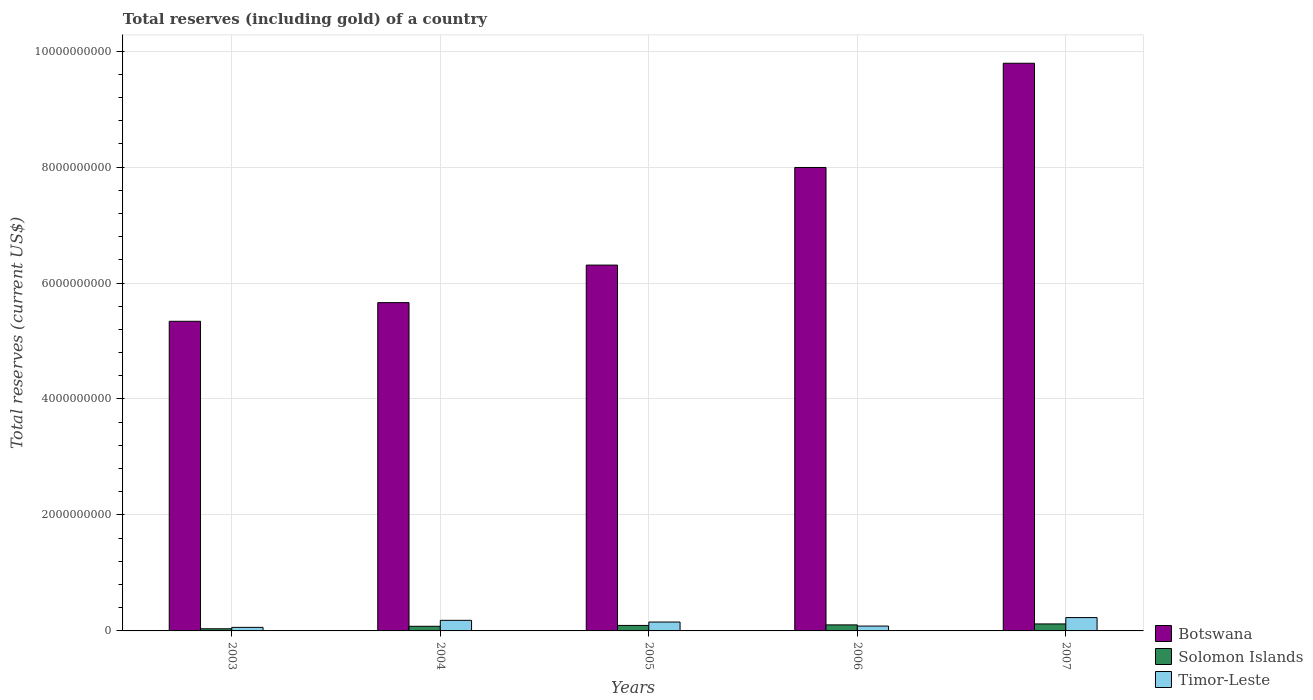How many different coloured bars are there?
Keep it short and to the point. 3. How many groups of bars are there?
Offer a very short reply. 5. Are the number of bars per tick equal to the number of legend labels?
Your answer should be very brief. Yes. Are the number of bars on each tick of the X-axis equal?
Your answer should be very brief. Yes. What is the label of the 3rd group of bars from the left?
Give a very brief answer. 2005. What is the total reserves (including gold) in Solomon Islands in 2006?
Keep it short and to the point. 1.04e+08. Across all years, what is the maximum total reserves (including gold) in Timor-Leste?
Offer a terse response. 2.30e+08. Across all years, what is the minimum total reserves (including gold) in Botswana?
Provide a short and direct response. 5.34e+09. In which year was the total reserves (including gold) in Timor-Leste maximum?
Provide a short and direct response. 2007. What is the total total reserves (including gold) in Botswana in the graph?
Your response must be concise. 3.51e+1. What is the difference between the total reserves (including gold) in Timor-Leste in 2003 and that in 2006?
Give a very brief answer. -2.25e+07. What is the difference between the total reserves (including gold) in Timor-Leste in 2003 and the total reserves (including gold) in Solomon Islands in 2006?
Give a very brief answer. -4.28e+07. What is the average total reserves (including gold) in Solomon Islands per year?
Offer a very short reply. 8.72e+07. In the year 2007, what is the difference between the total reserves (including gold) in Timor-Leste and total reserves (including gold) in Botswana?
Offer a terse response. -9.56e+09. In how many years, is the total reserves (including gold) in Timor-Leste greater than 4000000000 US$?
Provide a short and direct response. 0. What is the ratio of the total reserves (including gold) in Timor-Leste in 2003 to that in 2004?
Give a very brief answer. 0.34. Is the difference between the total reserves (including gold) in Timor-Leste in 2003 and 2006 greater than the difference between the total reserves (including gold) in Botswana in 2003 and 2006?
Your response must be concise. Yes. What is the difference between the highest and the second highest total reserves (including gold) in Solomon Islands?
Offer a very short reply. 1.65e+07. What is the difference between the highest and the lowest total reserves (including gold) in Timor-Leste?
Give a very brief answer. 1.69e+08. In how many years, is the total reserves (including gold) in Solomon Islands greater than the average total reserves (including gold) in Solomon Islands taken over all years?
Offer a very short reply. 3. Is the sum of the total reserves (including gold) in Solomon Islands in 2004 and 2005 greater than the maximum total reserves (including gold) in Timor-Leste across all years?
Your answer should be very brief. No. What does the 1st bar from the left in 2007 represents?
Make the answer very short. Botswana. What does the 2nd bar from the right in 2007 represents?
Your response must be concise. Solomon Islands. How many bars are there?
Ensure brevity in your answer.  15. Are the values on the major ticks of Y-axis written in scientific E-notation?
Keep it short and to the point. No. Does the graph contain any zero values?
Provide a succinct answer. No. Does the graph contain grids?
Make the answer very short. Yes. How are the legend labels stacked?
Your answer should be compact. Vertical. What is the title of the graph?
Offer a very short reply. Total reserves (including gold) of a country. What is the label or title of the Y-axis?
Your answer should be compact. Total reserves (current US$). What is the Total reserves (current US$) of Botswana in 2003?
Provide a short and direct response. 5.34e+09. What is the Total reserves (current US$) of Solomon Islands in 2003?
Provide a succinct answer. 3.70e+07. What is the Total reserves (current US$) of Timor-Leste in 2003?
Offer a terse response. 6.13e+07. What is the Total reserves (current US$) in Botswana in 2004?
Your response must be concise. 5.66e+09. What is the Total reserves (current US$) of Solomon Islands in 2004?
Your response must be concise. 7.98e+07. What is the Total reserves (current US$) in Timor-Leste in 2004?
Offer a very short reply. 1.82e+08. What is the Total reserves (current US$) in Botswana in 2005?
Provide a succinct answer. 6.31e+09. What is the Total reserves (current US$) of Solomon Islands in 2005?
Your answer should be very brief. 9.48e+07. What is the Total reserves (current US$) of Timor-Leste in 2005?
Your answer should be compact. 1.53e+08. What is the Total reserves (current US$) in Botswana in 2006?
Keep it short and to the point. 7.99e+09. What is the Total reserves (current US$) of Solomon Islands in 2006?
Offer a very short reply. 1.04e+08. What is the Total reserves (current US$) of Timor-Leste in 2006?
Give a very brief answer. 8.38e+07. What is the Total reserves (current US$) of Botswana in 2007?
Provide a short and direct response. 9.79e+09. What is the Total reserves (current US$) in Solomon Islands in 2007?
Give a very brief answer. 1.21e+08. What is the Total reserves (current US$) of Timor-Leste in 2007?
Keep it short and to the point. 2.30e+08. Across all years, what is the maximum Total reserves (current US$) in Botswana?
Ensure brevity in your answer.  9.79e+09. Across all years, what is the maximum Total reserves (current US$) of Solomon Islands?
Make the answer very short. 1.21e+08. Across all years, what is the maximum Total reserves (current US$) of Timor-Leste?
Provide a succinct answer. 2.30e+08. Across all years, what is the minimum Total reserves (current US$) of Botswana?
Ensure brevity in your answer.  5.34e+09. Across all years, what is the minimum Total reserves (current US$) in Solomon Islands?
Provide a succinct answer. 3.70e+07. Across all years, what is the minimum Total reserves (current US$) in Timor-Leste?
Provide a succinct answer. 6.13e+07. What is the total Total reserves (current US$) of Botswana in the graph?
Ensure brevity in your answer.  3.51e+1. What is the total Total reserves (current US$) of Solomon Islands in the graph?
Give a very brief answer. 4.36e+08. What is the total Total reserves (current US$) of Timor-Leste in the graph?
Give a very brief answer. 7.11e+08. What is the difference between the Total reserves (current US$) of Botswana in 2003 and that in 2004?
Offer a very short reply. -3.22e+08. What is the difference between the Total reserves (current US$) of Solomon Islands in 2003 and that in 2004?
Offer a very short reply. -4.28e+07. What is the difference between the Total reserves (current US$) in Timor-Leste in 2003 and that in 2004?
Give a very brief answer. -1.21e+08. What is the difference between the Total reserves (current US$) in Botswana in 2003 and that in 2005?
Give a very brief answer. -9.69e+08. What is the difference between the Total reserves (current US$) of Solomon Islands in 2003 and that in 2005?
Offer a very short reply. -5.78e+07. What is the difference between the Total reserves (current US$) of Timor-Leste in 2003 and that in 2005?
Your response must be concise. -9.20e+07. What is the difference between the Total reserves (current US$) in Botswana in 2003 and that in 2006?
Your answer should be compact. -2.65e+09. What is the difference between the Total reserves (current US$) in Solomon Islands in 2003 and that in 2006?
Provide a succinct answer. -6.71e+07. What is the difference between the Total reserves (current US$) of Timor-Leste in 2003 and that in 2006?
Your answer should be compact. -2.25e+07. What is the difference between the Total reserves (current US$) of Botswana in 2003 and that in 2007?
Your answer should be compact. -4.45e+09. What is the difference between the Total reserves (current US$) in Solomon Islands in 2003 and that in 2007?
Offer a terse response. -8.35e+07. What is the difference between the Total reserves (current US$) in Timor-Leste in 2003 and that in 2007?
Provide a succinct answer. -1.69e+08. What is the difference between the Total reserves (current US$) in Botswana in 2004 and that in 2005?
Your answer should be compact. -6.48e+08. What is the difference between the Total reserves (current US$) of Solomon Islands in 2004 and that in 2005?
Ensure brevity in your answer.  -1.50e+07. What is the difference between the Total reserves (current US$) of Timor-Leste in 2004 and that in 2005?
Provide a short and direct response. 2.91e+07. What is the difference between the Total reserves (current US$) in Botswana in 2004 and that in 2006?
Offer a terse response. -2.33e+09. What is the difference between the Total reserves (current US$) of Solomon Islands in 2004 and that in 2006?
Your response must be concise. -2.43e+07. What is the difference between the Total reserves (current US$) of Timor-Leste in 2004 and that in 2006?
Give a very brief answer. 9.87e+07. What is the difference between the Total reserves (current US$) of Botswana in 2004 and that in 2007?
Keep it short and to the point. -4.13e+09. What is the difference between the Total reserves (current US$) in Solomon Islands in 2004 and that in 2007?
Ensure brevity in your answer.  -4.07e+07. What is the difference between the Total reserves (current US$) of Timor-Leste in 2004 and that in 2007?
Make the answer very short. -4.78e+07. What is the difference between the Total reserves (current US$) in Botswana in 2005 and that in 2006?
Your answer should be very brief. -1.68e+09. What is the difference between the Total reserves (current US$) in Solomon Islands in 2005 and that in 2006?
Your response must be concise. -9.25e+06. What is the difference between the Total reserves (current US$) of Timor-Leste in 2005 and that in 2006?
Your answer should be very brief. 6.95e+07. What is the difference between the Total reserves (current US$) of Botswana in 2005 and that in 2007?
Offer a terse response. -3.48e+09. What is the difference between the Total reserves (current US$) in Solomon Islands in 2005 and that in 2007?
Provide a short and direct response. -2.57e+07. What is the difference between the Total reserves (current US$) of Timor-Leste in 2005 and that in 2007?
Your response must be concise. -7.70e+07. What is the difference between the Total reserves (current US$) of Botswana in 2006 and that in 2007?
Provide a short and direct response. -1.80e+09. What is the difference between the Total reserves (current US$) of Solomon Islands in 2006 and that in 2007?
Give a very brief answer. -1.65e+07. What is the difference between the Total reserves (current US$) in Timor-Leste in 2006 and that in 2007?
Provide a short and direct response. -1.47e+08. What is the difference between the Total reserves (current US$) of Botswana in 2003 and the Total reserves (current US$) of Solomon Islands in 2004?
Give a very brief answer. 5.26e+09. What is the difference between the Total reserves (current US$) in Botswana in 2003 and the Total reserves (current US$) in Timor-Leste in 2004?
Offer a terse response. 5.16e+09. What is the difference between the Total reserves (current US$) of Solomon Islands in 2003 and the Total reserves (current US$) of Timor-Leste in 2004?
Your answer should be compact. -1.45e+08. What is the difference between the Total reserves (current US$) in Botswana in 2003 and the Total reserves (current US$) in Solomon Islands in 2005?
Keep it short and to the point. 5.24e+09. What is the difference between the Total reserves (current US$) in Botswana in 2003 and the Total reserves (current US$) in Timor-Leste in 2005?
Your response must be concise. 5.19e+09. What is the difference between the Total reserves (current US$) of Solomon Islands in 2003 and the Total reserves (current US$) of Timor-Leste in 2005?
Your response must be concise. -1.16e+08. What is the difference between the Total reserves (current US$) in Botswana in 2003 and the Total reserves (current US$) in Solomon Islands in 2006?
Give a very brief answer. 5.24e+09. What is the difference between the Total reserves (current US$) in Botswana in 2003 and the Total reserves (current US$) in Timor-Leste in 2006?
Ensure brevity in your answer.  5.26e+09. What is the difference between the Total reserves (current US$) of Solomon Islands in 2003 and the Total reserves (current US$) of Timor-Leste in 2006?
Keep it short and to the point. -4.67e+07. What is the difference between the Total reserves (current US$) in Botswana in 2003 and the Total reserves (current US$) in Solomon Islands in 2007?
Keep it short and to the point. 5.22e+09. What is the difference between the Total reserves (current US$) in Botswana in 2003 and the Total reserves (current US$) in Timor-Leste in 2007?
Keep it short and to the point. 5.11e+09. What is the difference between the Total reserves (current US$) in Solomon Islands in 2003 and the Total reserves (current US$) in Timor-Leste in 2007?
Ensure brevity in your answer.  -1.93e+08. What is the difference between the Total reserves (current US$) in Botswana in 2004 and the Total reserves (current US$) in Solomon Islands in 2005?
Offer a very short reply. 5.57e+09. What is the difference between the Total reserves (current US$) in Botswana in 2004 and the Total reserves (current US$) in Timor-Leste in 2005?
Your response must be concise. 5.51e+09. What is the difference between the Total reserves (current US$) in Solomon Islands in 2004 and the Total reserves (current US$) in Timor-Leste in 2005?
Provide a short and direct response. -7.35e+07. What is the difference between the Total reserves (current US$) of Botswana in 2004 and the Total reserves (current US$) of Solomon Islands in 2006?
Keep it short and to the point. 5.56e+09. What is the difference between the Total reserves (current US$) of Botswana in 2004 and the Total reserves (current US$) of Timor-Leste in 2006?
Offer a terse response. 5.58e+09. What is the difference between the Total reserves (current US$) of Solomon Islands in 2004 and the Total reserves (current US$) of Timor-Leste in 2006?
Offer a very short reply. -3.94e+06. What is the difference between the Total reserves (current US$) in Botswana in 2004 and the Total reserves (current US$) in Solomon Islands in 2007?
Provide a succinct answer. 5.54e+09. What is the difference between the Total reserves (current US$) in Botswana in 2004 and the Total reserves (current US$) in Timor-Leste in 2007?
Give a very brief answer. 5.43e+09. What is the difference between the Total reserves (current US$) in Solomon Islands in 2004 and the Total reserves (current US$) in Timor-Leste in 2007?
Provide a short and direct response. -1.50e+08. What is the difference between the Total reserves (current US$) in Botswana in 2005 and the Total reserves (current US$) in Solomon Islands in 2006?
Your answer should be very brief. 6.20e+09. What is the difference between the Total reserves (current US$) in Botswana in 2005 and the Total reserves (current US$) in Timor-Leste in 2006?
Provide a succinct answer. 6.23e+09. What is the difference between the Total reserves (current US$) in Solomon Islands in 2005 and the Total reserves (current US$) in Timor-Leste in 2006?
Offer a very short reply. 1.11e+07. What is the difference between the Total reserves (current US$) in Botswana in 2005 and the Total reserves (current US$) in Solomon Islands in 2007?
Provide a short and direct response. 6.19e+09. What is the difference between the Total reserves (current US$) in Botswana in 2005 and the Total reserves (current US$) in Timor-Leste in 2007?
Give a very brief answer. 6.08e+09. What is the difference between the Total reserves (current US$) of Solomon Islands in 2005 and the Total reserves (current US$) of Timor-Leste in 2007?
Your response must be concise. -1.35e+08. What is the difference between the Total reserves (current US$) of Botswana in 2006 and the Total reserves (current US$) of Solomon Islands in 2007?
Keep it short and to the point. 7.87e+09. What is the difference between the Total reserves (current US$) of Botswana in 2006 and the Total reserves (current US$) of Timor-Leste in 2007?
Your response must be concise. 7.76e+09. What is the difference between the Total reserves (current US$) in Solomon Islands in 2006 and the Total reserves (current US$) in Timor-Leste in 2007?
Offer a terse response. -1.26e+08. What is the average Total reserves (current US$) of Botswana per year?
Keep it short and to the point. 7.02e+09. What is the average Total reserves (current US$) of Solomon Islands per year?
Provide a succinct answer. 8.72e+07. What is the average Total reserves (current US$) of Timor-Leste per year?
Keep it short and to the point. 1.42e+08. In the year 2003, what is the difference between the Total reserves (current US$) in Botswana and Total reserves (current US$) in Solomon Islands?
Provide a succinct answer. 5.30e+09. In the year 2003, what is the difference between the Total reserves (current US$) in Botswana and Total reserves (current US$) in Timor-Leste?
Offer a very short reply. 5.28e+09. In the year 2003, what is the difference between the Total reserves (current US$) of Solomon Islands and Total reserves (current US$) of Timor-Leste?
Give a very brief answer. -2.43e+07. In the year 2004, what is the difference between the Total reserves (current US$) in Botswana and Total reserves (current US$) in Solomon Islands?
Provide a succinct answer. 5.58e+09. In the year 2004, what is the difference between the Total reserves (current US$) in Botswana and Total reserves (current US$) in Timor-Leste?
Make the answer very short. 5.48e+09. In the year 2004, what is the difference between the Total reserves (current US$) in Solomon Islands and Total reserves (current US$) in Timor-Leste?
Offer a very short reply. -1.03e+08. In the year 2005, what is the difference between the Total reserves (current US$) of Botswana and Total reserves (current US$) of Solomon Islands?
Your response must be concise. 6.21e+09. In the year 2005, what is the difference between the Total reserves (current US$) of Botswana and Total reserves (current US$) of Timor-Leste?
Your answer should be very brief. 6.16e+09. In the year 2005, what is the difference between the Total reserves (current US$) in Solomon Islands and Total reserves (current US$) in Timor-Leste?
Your response must be concise. -5.85e+07. In the year 2006, what is the difference between the Total reserves (current US$) of Botswana and Total reserves (current US$) of Solomon Islands?
Ensure brevity in your answer.  7.89e+09. In the year 2006, what is the difference between the Total reserves (current US$) of Botswana and Total reserves (current US$) of Timor-Leste?
Provide a succinct answer. 7.91e+09. In the year 2006, what is the difference between the Total reserves (current US$) in Solomon Islands and Total reserves (current US$) in Timor-Leste?
Give a very brief answer. 2.03e+07. In the year 2007, what is the difference between the Total reserves (current US$) in Botswana and Total reserves (current US$) in Solomon Islands?
Provide a short and direct response. 9.67e+09. In the year 2007, what is the difference between the Total reserves (current US$) in Botswana and Total reserves (current US$) in Timor-Leste?
Give a very brief answer. 9.56e+09. In the year 2007, what is the difference between the Total reserves (current US$) of Solomon Islands and Total reserves (current US$) of Timor-Leste?
Keep it short and to the point. -1.10e+08. What is the ratio of the Total reserves (current US$) of Botswana in 2003 to that in 2004?
Give a very brief answer. 0.94. What is the ratio of the Total reserves (current US$) of Solomon Islands in 2003 to that in 2004?
Keep it short and to the point. 0.46. What is the ratio of the Total reserves (current US$) in Timor-Leste in 2003 to that in 2004?
Provide a short and direct response. 0.34. What is the ratio of the Total reserves (current US$) in Botswana in 2003 to that in 2005?
Your answer should be compact. 0.85. What is the ratio of the Total reserves (current US$) of Solomon Islands in 2003 to that in 2005?
Your answer should be very brief. 0.39. What is the ratio of the Total reserves (current US$) in Timor-Leste in 2003 to that in 2005?
Ensure brevity in your answer.  0.4. What is the ratio of the Total reserves (current US$) of Botswana in 2003 to that in 2006?
Make the answer very short. 0.67. What is the ratio of the Total reserves (current US$) in Solomon Islands in 2003 to that in 2006?
Give a very brief answer. 0.36. What is the ratio of the Total reserves (current US$) of Timor-Leste in 2003 to that in 2006?
Your answer should be compact. 0.73. What is the ratio of the Total reserves (current US$) of Botswana in 2003 to that in 2007?
Offer a very short reply. 0.55. What is the ratio of the Total reserves (current US$) of Solomon Islands in 2003 to that in 2007?
Make the answer very short. 0.31. What is the ratio of the Total reserves (current US$) in Timor-Leste in 2003 to that in 2007?
Offer a terse response. 0.27. What is the ratio of the Total reserves (current US$) in Botswana in 2004 to that in 2005?
Offer a very short reply. 0.9. What is the ratio of the Total reserves (current US$) of Solomon Islands in 2004 to that in 2005?
Ensure brevity in your answer.  0.84. What is the ratio of the Total reserves (current US$) in Timor-Leste in 2004 to that in 2005?
Provide a short and direct response. 1.19. What is the ratio of the Total reserves (current US$) of Botswana in 2004 to that in 2006?
Your response must be concise. 0.71. What is the ratio of the Total reserves (current US$) of Solomon Islands in 2004 to that in 2006?
Your answer should be very brief. 0.77. What is the ratio of the Total reserves (current US$) of Timor-Leste in 2004 to that in 2006?
Ensure brevity in your answer.  2.18. What is the ratio of the Total reserves (current US$) of Botswana in 2004 to that in 2007?
Make the answer very short. 0.58. What is the ratio of the Total reserves (current US$) in Solomon Islands in 2004 to that in 2007?
Give a very brief answer. 0.66. What is the ratio of the Total reserves (current US$) in Timor-Leste in 2004 to that in 2007?
Offer a terse response. 0.79. What is the ratio of the Total reserves (current US$) in Botswana in 2005 to that in 2006?
Provide a succinct answer. 0.79. What is the ratio of the Total reserves (current US$) in Solomon Islands in 2005 to that in 2006?
Your answer should be compact. 0.91. What is the ratio of the Total reserves (current US$) in Timor-Leste in 2005 to that in 2006?
Your answer should be compact. 1.83. What is the ratio of the Total reserves (current US$) in Botswana in 2005 to that in 2007?
Provide a short and direct response. 0.64. What is the ratio of the Total reserves (current US$) in Solomon Islands in 2005 to that in 2007?
Your answer should be very brief. 0.79. What is the ratio of the Total reserves (current US$) in Timor-Leste in 2005 to that in 2007?
Make the answer very short. 0.67. What is the ratio of the Total reserves (current US$) in Botswana in 2006 to that in 2007?
Offer a terse response. 0.82. What is the ratio of the Total reserves (current US$) of Solomon Islands in 2006 to that in 2007?
Your response must be concise. 0.86. What is the ratio of the Total reserves (current US$) of Timor-Leste in 2006 to that in 2007?
Offer a very short reply. 0.36. What is the difference between the highest and the second highest Total reserves (current US$) in Botswana?
Ensure brevity in your answer.  1.80e+09. What is the difference between the highest and the second highest Total reserves (current US$) of Solomon Islands?
Keep it short and to the point. 1.65e+07. What is the difference between the highest and the second highest Total reserves (current US$) in Timor-Leste?
Your answer should be compact. 4.78e+07. What is the difference between the highest and the lowest Total reserves (current US$) of Botswana?
Your response must be concise. 4.45e+09. What is the difference between the highest and the lowest Total reserves (current US$) of Solomon Islands?
Your response must be concise. 8.35e+07. What is the difference between the highest and the lowest Total reserves (current US$) in Timor-Leste?
Your answer should be compact. 1.69e+08. 